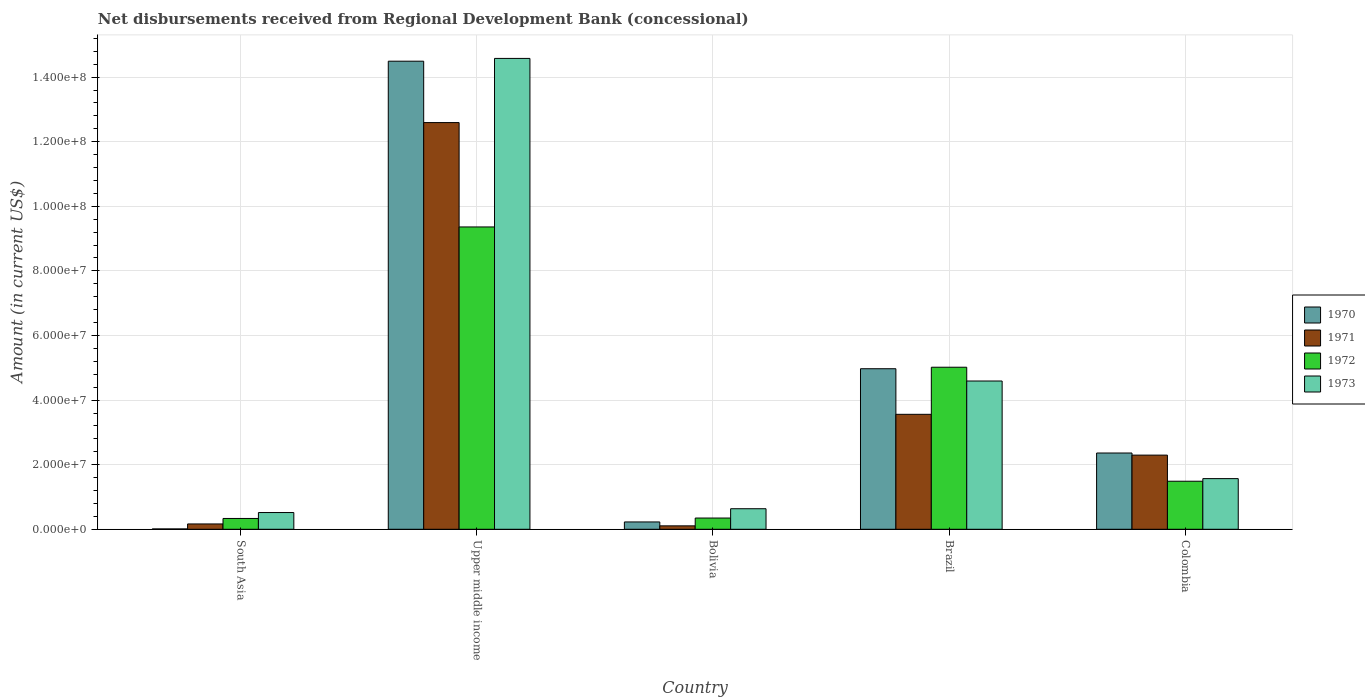How many different coloured bars are there?
Your response must be concise. 4. How many groups of bars are there?
Give a very brief answer. 5. Are the number of bars per tick equal to the number of legend labels?
Provide a short and direct response. Yes. How many bars are there on the 5th tick from the right?
Your answer should be very brief. 4. What is the label of the 2nd group of bars from the left?
Make the answer very short. Upper middle income. What is the amount of disbursements received from Regional Development Bank in 1972 in Bolivia?
Ensure brevity in your answer.  3.48e+06. Across all countries, what is the maximum amount of disbursements received from Regional Development Bank in 1973?
Ensure brevity in your answer.  1.46e+08. Across all countries, what is the minimum amount of disbursements received from Regional Development Bank in 1971?
Your response must be concise. 1.06e+06. In which country was the amount of disbursements received from Regional Development Bank in 1973 maximum?
Give a very brief answer. Upper middle income. In which country was the amount of disbursements received from Regional Development Bank in 1972 minimum?
Provide a short and direct response. South Asia. What is the total amount of disbursements received from Regional Development Bank in 1973 in the graph?
Offer a terse response. 2.19e+08. What is the difference between the amount of disbursements received from Regional Development Bank in 1970 in Brazil and that in South Asia?
Keep it short and to the point. 4.96e+07. What is the difference between the amount of disbursements received from Regional Development Bank in 1970 in Upper middle income and the amount of disbursements received from Regional Development Bank in 1973 in Brazil?
Ensure brevity in your answer.  9.90e+07. What is the average amount of disbursements received from Regional Development Bank in 1973 per country?
Your answer should be very brief. 4.38e+07. What is the difference between the amount of disbursements received from Regional Development Bank of/in 1972 and amount of disbursements received from Regional Development Bank of/in 1971 in Bolivia?
Give a very brief answer. 2.42e+06. In how many countries, is the amount of disbursements received from Regional Development Bank in 1970 greater than 100000000 US$?
Provide a succinct answer. 1. What is the ratio of the amount of disbursements received from Regional Development Bank in 1971 in Brazil to that in Upper middle income?
Your answer should be compact. 0.28. Is the amount of disbursements received from Regional Development Bank in 1970 in Bolivia less than that in Upper middle income?
Make the answer very short. Yes. Is the difference between the amount of disbursements received from Regional Development Bank in 1972 in South Asia and Upper middle income greater than the difference between the amount of disbursements received from Regional Development Bank in 1971 in South Asia and Upper middle income?
Give a very brief answer. Yes. What is the difference between the highest and the second highest amount of disbursements received from Regional Development Bank in 1972?
Your answer should be compact. 4.34e+07. What is the difference between the highest and the lowest amount of disbursements received from Regional Development Bank in 1970?
Make the answer very short. 1.45e+08. In how many countries, is the amount of disbursements received from Regional Development Bank in 1973 greater than the average amount of disbursements received from Regional Development Bank in 1973 taken over all countries?
Ensure brevity in your answer.  2. Is the sum of the amount of disbursements received from Regional Development Bank in 1973 in Bolivia and Brazil greater than the maximum amount of disbursements received from Regional Development Bank in 1971 across all countries?
Ensure brevity in your answer.  No. Is it the case that in every country, the sum of the amount of disbursements received from Regional Development Bank in 1973 and amount of disbursements received from Regional Development Bank in 1971 is greater than the sum of amount of disbursements received from Regional Development Bank in 1970 and amount of disbursements received from Regional Development Bank in 1972?
Ensure brevity in your answer.  No. Are all the bars in the graph horizontal?
Provide a short and direct response. No. How many countries are there in the graph?
Provide a succinct answer. 5. Does the graph contain grids?
Provide a short and direct response. Yes. Where does the legend appear in the graph?
Make the answer very short. Center right. How are the legend labels stacked?
Ensure brevity in your answer.  Vertical. What is the title of the graph?
Give a very brief answer. Net disbursements received from Regional Development Bank (concessional). Does "1986" appear as one of the legend labels in the graph?
Your answer should be compact. No. What is the Amount (in current US$) in 1970 in South Asia?
Make the answer very short. 1.09e+05. What is the Amount (in current US$) of 1971 in South Asia?
Your answer should be very brief. 1.65e+06. What is the Amount (in current US$) of 1972 in South Asia?
Your response must be concise. 3.35e+06. What is the Amount (in current US$) in 1973 in South Asia?
Provide a succinct answer. 5.18e+06. What is the Amount (in current US$) in 1970 in Upper middle income?
Your answer should be compact. 1.45e+08. What is the Amount (in current US$) of 1971 in Upper middle income?
Your answer should be compact. 1.26e+08. What is the Amount (in current US$) of 1972 in Upper middle income?
Provide a succinct answer. 9.36e+07. What is the Amount (in current US$) of 1973 in Upper middle income?
Your response must be concise. 1.46e+08. What is the Amount (in current US$) of 1970 in Bolivia?
Your answer should be compact. 2.27e+06. What is the Amount (in current US$) in 1971 in Bolivia?
Make the answer very short. 1.06e+06. What is the Amount (in current US$) in 1972 in Bolivia?
Offer a terse response. 3.48e+06. What is the Amount (in current US$) of 1973 in Bolivia?
Your answer should be very brief. 6.36e+06. What is the Amount (in current US$) of 1970 in Brazil?
Make the answer very short. 4.97e+07. What is the Amount (in current US$) of 1971 in Brazil?
Keep it short and to the point. 3.56e+07. What is the Amount (in current US$) of 1972 in Brazil?
Provide a short and direct response. 5.02e+07. What is the Amount (in current US$) of 1973 in Brazil?
Your answer should be compact. 4.59e+07. What is the Amount (in current US$) in 1970 in Colombia?
Ensure brevity in your answer.  2.36e+07. What is the Amount (in current US$) of 1971 in Colombia?
Your response must be concise. 2.30e+07. What is the Amount (in current US$) of 1972 in Colombia?
Keep it short and to the point. 1.49e+07. What is the Amount (in current US$) of 1973 in Colombia?
Your answer should be compact. 1.57e+07. Across all countries, what is the maximum Amount (in current US$) of 1970?
Your response must be concise. 1.45e+08. Across all countries, what is the maximum Amount (in current US$) of 1971?
Offer a very short reply. 1.26e+08. Across all countries, what is the maximum Amount (in current US$) of 1972?
Make the answer very short. 9.36e+07. Across all countries, what is the maximum Amount (in current US$) in 1973?
Provide a succinct answer. 1.46e+08. Across all countries, what is the minimum Amount (in current US$) in 1970?
Ensure brevity in your answer.  1.09e+05. Across all countries, what is the minimum Amount (in current US$) of 1971?
Make the answer very short. 1.06e+06. Across all countries, what is the minimum Amount (in current US$) of 1972?
Provide a succinct answer. 3.35e+06. Across all countries, what is the minimum Amount (in current US$) in 1973?
Keep it short and to the point. 5.18e+06. What is the total Amount (in current US$) of 1970 in the graph?
Keep it short and to the point. 2.21e+08. What is the total Amount (in current US$) in 1971 in the graph?
Make the answer very short. 1.87e+08. What is the total Amount (in current US$) in 1972 in the graph?
Your answer should be very brief. 1.65e+08. What is the total Amount (in current US$) in 1973 in the graph?
Your response must be concise. 2.19e+08. What is the difference between the Amount (in current US$) in 1970 in South Asia and that in Upper middle income?
Provide a short and direct response. -1.45e+08. What is the difference between the Amount (in current US$) in 1971 in South Asia and that in Upper middle income?
Offer a terse response. -1.24e+08. What is the difference between the Amount (in current US$) of 1972 in South Asia and that in Upper middle income?
Give a very brief answer. -9.03e+07. What is the difference between the Amount (in current US$) in 1973 in South Asia and that in Upper middle income?
Keep it short and to the point. -1.41e+08. What is the difference between the Amount (in current US$) of 1970 in South Asia and that in Bolivia?
Your answer should be very brief. -2.16e+06. What is the difference between the Amount (in current US$) in 1971 in South Asia and that in Bolivia?
Offer a terse response. 5.92e+05. What is the difference between the Amount (in current US$) of 1972 in South Asia and that in Bolivia?
Offer a terse response. -1.30e+05. What is the difference between the Amount (in current US$) in 1973 in South Asia and that in Bolivia?
Ensure brevity in your answer.  -1.18e+06. What is the difference between the Amount (in current US$) of 1970 in South Asia and that in Brazil?
Keep it short and to the point. -4.96e+07. What is the difference between the Amount (in current US$) of 1971 in South Asia and that in Brazil?
Your answer should be compact. -3.39e+07. What is the difference between the Amount (in current US$) of 1972 in South Asia and that in Brazil?
Your response must be concise. -4.68e+07. What is the difference between the Amount (in current US$) in 1973 in South Asia and that in Brazil?
Give a very brief answer. -4.07e+07. What is the difference between the Amount (in current US$) in 1970 in South Asia and that in Colombia?
Ensure brevity in your answer.  -2.35e+07. What is the difference between the Amount (in current US$) in 1971 in South Asia and that in Colombia?
Keep it short and to the point. -2.13e+07. What is the difference between the Amount (in current US$) in 1972 in South Asia and that in Colombia?
Offer a very short reply. -1.15e+07. What is the difference between the Amount (in current US$) of 1973 in South Asia and that in Colombia?
Offer a very short reply. -1.05e+07. What is the difference between the Amount (in current US$) of 1970 in Upper middle income and that in Bolivia?
Your answer should be compact. 1.43e+08. What is the difference between the Amount (in current US$) in 1971 in Upper middle income and that in Bolivia?
Offer a terse response. 1.25e+08. What is the difference between the Amount (in current US$) of 1972 in Upper middle income and that in Bolivia?
Ensure brevity in your answer.  9.01e+07. What is the difference between the Amount (in current US$) of 1973 in Upper middle income and that in Bolivia?
Ensure brevity in your answer.  1.39e+08. What is the difference between the Amount (in current US$) in 1970 in Upper middle income and that in Brazil?
Your answer should be compact. 9.52e+07. What is the difference between the Amount (in current US$) in 1971 in Upper middle income and that in Brazil?
Your answer should be compact. 9.03e+07. What is the difference between the Amount (in current US$) in 1972 in Upper middle income and that in Brazil?
Make the answer very short. 4.34e+07. What is the difference between the Amount (in current US$) in 1973 in Upper middle income and that in Brazil?
Keep it short and to the point. 9.99e+07. What is the difference between the Amount (in current US$) in 1970 in Upper middle income and that in Colombia?
Your answer should be compact. 1.21e+08. What is the difference between the Amount (in current US$) in 1971 in Upper middle income and that in Colombia?
Your answer should be very brief. 1.03e+08. What is the difference between the Amount (in current US$) in 1972 in Upper middle income and that in Colombia?
Keep it short and to the point. 7.87e+07. What is the difference between the Amount (in current US$) in 1973 in Upper middle income and that in Colombia?
Ensure brevity in your answer.  1.30e+08. What is the difference between the Amount (in current US$) of 1970 in Bolivia and that in Brazil?
Your response must be concise. -4.74e+07. What is the difference between the Amount (in current US$) of 1971 in Bolivia and that in Brazil?
Make the answer very short. -3.45e+07. What is the difference between the Amount (in current US$) in 1972 in Bolivia and that in Brazil?
Your answer should be very brief. -4.67e+07. What is the difference between the Amount (in current US$) in 1973 in Bolivia and that in Brazil?
Your answer should be compact. -3.95e+07. What is the difference between the Amount (in current US$) of 1970 in Bolivia and that in Colombia?
Your response must be concise. -2.13e+07. What is the difference between the Amount (in current US$) in 1971 in Bolivia and that in Colombia?
Provide a short and direct response. -2.19e+07. What is the difference between the Amount (in current US$) of 1972 in Bolivia and that in Colombia?
Give a very brief answer. -1.14e+07. What is the difference between the Amount (in current US$) of 1973 in Bolivia and that in Colombia?
Your answer should be compact. -9.33e+06. What is the difference between the Amount (in current US$) of 1970 in Brazil and that in Colombia?
Your response must be concise. 2.61e+07. What is the difference between the Amount (in current US$) of 1971 in Brazil and that in Colombia?
Provide a succinct answer. 1.26e+07. What is the difference between the Amount (in current US$) of 1972 in Brazil and that in Colombia?
Your answer should be very brief. 3.53e+07. What is the difference between the Amount (in current US$) in 1973 in Brazil and that in Colombia?
Make the answer very short. 3.02e+07. What is the difference between the Amount (in current US$) of 1970 in South Asia and the Amount (in current US$) of 1971 in Upper middle income?
Keep it short and to the point. -1.26e+08. What is the difference between the Amount (in current US$) of 1970 in South Asia and the Amount (in current US$) of 1972 in Upper middle income?
Offer a terse response. -9.35e+07. What is the difference between the Amount (in current US$) of 1970 in South Asia and the Amount (in current US$) of 1973 in Upper middle income?
Provide a succinct answer. -1.46e+08. What is the difference between the Amount (in current US$) in 1971 in South Asia and the Amount (in current US$) in 1972 in Upper middle income?
Provide a short and direct response. -9.20e+07. What is the difference between the Amount (in current US$) in 1971 in South Asia and the Amount (in current US$) in 1973 in Upper middle income?
Give a very brief answer. -1.44e+08. What is the difference between the Amount (in current US$) of 1972 in South Asia and the Amount (in current US$) of 1973 in Upper middle income?
Offer a very short reply. -1.42e+08. What is the difference between the Amount (in current US$) of 1970 in South Asia and the Amount (in current US$) of 1971 in Bolivia?
Offer a terse response. -9.49e+05. What is the difference between the Amount (in current US$) of 1970 in South Asia and the Amount (in current US$) of 1972 in Bolivia?
Ensure brevity in your answer.  -3.37e+06. What is the difference between the Amount (in current US$) of 1970 in South Asia and the Amount (in current US$) of 1973 in Bolivia?
Your answer should be compact. -6.25e+06. What is the difference between the Amount (in current US$) of 1971 in South Asia and the Amount (in current US$) of 1972 in Bolivia?
Ensure brevity in your answer.  -1.83e+06. What is the difference between the Amount (in current US$) in 1971 in South Asia and the Amount (in current US$) in 1973 in Bolivia?
Provide a succinct answer. -4.71e+06. What is the difference between the Amount (in current US$) of 1972 in South Asia and the Amount (in current US$) of 1973 in Bolivia?
Ensure brevity in your answer.  -3.01e+06. What is the difference between the Amount (in current US$) in 1970 in South Asia and the Amount (in current US$) in 1971 in Brazil?
Provide a succinct answer. -3.55e+07. What is the difference between the Amount (in current US$) of 1970 in South Asia and the Amount (in current US$) of 1972 in Brazil?
Your answer should be very brief. -5.01e+07. What is the difference between the Amount (in current US$) of 1970 in South Asia and the Amount (in current US$) of 1973 in Brazil?
Give a very brief answer. -4.58e+07. What is the difference between the Amount (in current US$) in 1971 in South Asia and the Amount (in current US$) in 1972 in Brazil?
Offer a terse response. -4.85e+07. What is the difference between the Amount (in current US$) in 1971 in South Asia and the Amount (in current US$) in 1973 in Brazil?
Keep it short and to the point. -4.43e+07. What is the difference between the Amount (in current US$) of 1972 in South Asia and the Amount (in current US$) of 1973 in Brazil?
Keep it short and to the point. -4.26e+07. What is the difference between the Amount (in current US$) of 1970 in South Asia and the Amount (in current US$) of 1971 in Colombia?
Your response must be concise. -2.29e+07. What is the difference between the Amount (in current US$) of 1970 in South Asia and the Amount (in current US$) of 1972 in Colombia?
Offer a very short reply. -1.48e+07. What is the difference between the Amount (in current US$) of 1970 in South Asia and the Amount (in current US$) of 1973 in Colombia?
Your response must be concise. -1.56e+07. What is the difference between the Amount (in current US$) in 1971 in South Asia and the Amount (in current US$) in 1972 in Colombia?
Keep it short and to the point. -1.32e+07. What is the difference between the Amount (in current US$) in 1971 in South Asia and the Amount (in current US$) in 1973 in Colombia?
Keep it short and to the point. -1.40e+07. What is the difference between the Amount (in current US$) in 1972 in South Asia and the Amount (in current US$) in 1973 in Colombia?
Offer a very short reply. -1.23e+07. What is the difference between the Amount (in current US$) of 1970 in Upper middle income and the Amount (in current US$) of 1971 in Bolivia?
Your response must be concise. 1.44e+08. What is the difference between the Amount (in current US$) in 1970 in Upper middle income and the Amount (in current US$) in 1972 in Bolivia?
Provide a succinct answer. 1.41e+08. What is the difference between the Amount (in current US$) in 1970 in Upper middle income and the Amount (in current US$) in 1973 in Bolivia?
Provide a succinct answer. 1.39e+08. What is the difference between the Amount (in current US$) of 1971 in Upper middle income and the Amount (in current US$) of 1972 in Bolivia?
Your answer should be very brief. 1.22e+08. What is the difference between the Amount (in current US$) in 1971 in Upper middle income and the Amount (in current US$) in 1973 in Bolivia?
Your response must be concise. 1.20e+08. What is the difference between the Amount (in current US$) in 1972 in Upper middle income and the Amount (in current US$) in 1973 in Bolivia?
Ensure brevity in your answer.  8.72e+07. What is the difference between the Amount (in current US$) of 1970 in Upper middle income and the Amount (in current US$) of 1971 in Brazil?
Your answer should be very brief. 1.09e+08. What is the difference between the Amount (in current US$) of 1970 in Upper middle income and the Amount (in current US$) of 1972 in Brazil?
Keep it short and to the point. 9.48e+07. What is the difference between the Amount (in current US$) of 1970 in Upper middle income and the Amount (in current US$) of 1973 in Brazil?
Offer a terse response. 9.90e+07. What is the difference between the Amount (in current US$) in 1971 in Upper middle income and the Amount (in current US$) in 1972 in Brazil?
Your answer should be compact. 7.57e+07. What is the difference between the Amount (in current US$) in 1971 in Upper middle income and the Amount (in current US$) in 1973 in Brazil?
Offer a terse response. 8.00e+07. What is the difference between the Amount (in current US$) of 1972 in Upper middle income and the Amount (in current US$) of 1973 in Brazil?
Give a very brief answer. 4.77e+07. What is the difference between the Amount (in current US$) of 1970 in Upper middle income and the Amount (in current US$) of 1971 in Colombia?
Your answer should be very brief. 1.22e+08. What is the difference between the Amount (in current US$) of 1970 in Upper middle income and the Amount (in current US$) of 1972 in Colombia?
Offer a terse response. 1.30e+08. What is the difference between the Amount (in current US$) in 1970 in Upper middle income and the Amount (in current US$) in 1973 in Colombia?
Your response must be concise. 1.29e+08. What is the difference between the Amount (in current US$) of 1971 in Upper middle income and the Amount (in current US$) of 1972 in Colombia?
Offer a terse response. 1.11e+08. What is the difference between the Amount (in current US$) of 1971 in Upper middle income and the Amount (in current US$) of 1973 in Colombia?
Provide a succinct answer. 1.10e+08. What is the difference between the Amount (in current US$) in 1972 in Upper middle income and the Amount (in current US$) in 1973 in Colombia?
Keep it short and to the point. 7.79e+07. What is the difference between the Amount (in current US$) of 1970 in Bolivia and the Amount (in current US$) of 1971 in Brazil?
Offer a terse response. -3.33e+07. What is the difference between the Amount (in current US$) of 1970 in Bolivia and the Amount (in current US$) of 1972 in Brazil?
Your answer should be compact. -4.79e+07. What is the difference between the Amount (in current US$) in 1970 in Bolivia and the Amount (in current US$) in 1973 in Brazil?
Your response must be concise. -4.36e+07. What is the difference between the Amount (in current US$) of 1971 in Bolivia and the Amount (in current US$) of 1972 in Brazil?
Provide a succinct answer. -4.91e+07. What is the difference between the Amount (in current US$) in 1971 in Bolivia and the Amount (in current US$) in 1973 in Brazil?
Provide a succinct answer. -4.49e+07. What is the difference between the Amount (in current US$) of 1972 in Bolivia and the Amount (in current US$) of 1973 in Brazil?
Give a very brief answer. -4.24e+07. What is the difference between the Amount (in current US$) in 1970 in Bolivia and the Amount (in current US$) in 1971 in Colombia?
Your answer should be compact. -2.07e+07. What is the difference between the Amount (in current US$) in 1970 in Bolivia and the Amount (in current US$) in 1972 in Colombia?
Ensure brevity in your answer.  -1.26e+07. What is the difference between the Amount (in current US$) in 1970 in Bolivia and the Amount (in current US$) in 1973 in Colombia?
Ensure brevity in your answer.  -1.34e+07. What is the difference between the Amount (in current US$) of 1971 in Bolivia and the Amount (in current US$) of 1972 in Colombia?
Your answer should be compact. -1.38e+07. What is the difference between the Amount (in current US$) of 1971 in Bolivia and the Amount (in current US$) of 1973 in Colombia?
Offer a terse response. -1.46e+07. What is the difference between the Amount (in current US$) of 1972 in Bolivia and the Amount (in current US$) of 1973 in Colombia?
Keep it short and to the point. -1.22e+07. What is the difference between the Amount (in current US$) in 1970 in Brazil and the Amount (in current US$) in 1971 in Colombia?
Ensure brevity in your answer.  2.67e+07. What is the difference between the Amount (in current US$) in 1970 in Brazil and the Amount (in current US$) in 1972 in Colombia?
Offer a very short reply. 3.48e+07. What is the difference between the Amount (in current US$) of 1970 in Brazil and the Amount (in current US$) of 1973 in Colombia?
Offer a very short reply. 3.40e+07. What is the difference between the Amount (in current US$) in 1971 in Brazil and the Amount (in current US$) in 1972 in Colombia?
Give a very brief answer. 2.07e+07. What is the difference between the Amount (in current US$) of 1971 in Brazil and the Amount (in current US$) of 1973 in Colombia?
Offer a terse response. 1.99e+07. What is the difference between the Amount (in current US$) in 1972 in Brazil and the Amount (in current US$) in 1973 in Colombia?
Provide a short and direct response. 3.45e+07. What is the average Amount (in current US$) in 1970 per country?
Offer a terse response. 4.41e+07. What is the average Amount (in current US$) in 1971 per country?
Provide a succinct answer. 3.74e+07. What is the average Amount (in current US$) in 1972 per country?
Give a very brief answer. 3.31e+07. What is the average Amount (in current US$) of 1973 per country?
Give a very brief answer. 4.38e+07. What is the difference between the Amount (in current US$) in 1970 and Amount (in current US$) in 1971 in South Asia?
Provide a short and direct response. -1.54e+06. What is the difference between the Amount (in current US$) of 1970 and Amount (in current US$) of 1972 in South Asia?
Give a very brief answer. -3.24e+06. What is the difference between the Amount (in current US$) in 1970 and Amount (in current US$) in 1973 in South Asia?
Your response must be concise. -5.08e+06. What is the difference between the Amount (in current US$) in 1971 and Amount (in current US$) in 1972 in South Asia?
Your response must be concise. -1.70e+06. What is the difference between the Amount (in current US$) of 1971 and Amount (in current US$) of 1973 in South Asia?
Your answer should be very brief. -3.53e+06. What is the difference between the Amount (in current US$) of 1972 and Amount (in current US$) of 1973 in South Asia?
Your response must be concise. -1.83e+06. What is the difference between the Amount (in current US$) of 1970 and Amount (in current US$) of 1971 in Upper middle income?
Your answer should be compact. 1.90e+07. What is the difference between the Amount (in current US$) in 1970 and Amount (in current US$) in 1972 in Upper middle income?
Your answer should be very brief. 5.13e+07. What is the difference between the Amount (in current US$) of 1970 and Amount (in current US$) of 1973 in Upper middle income?
Offer a very short reply. -8.58e+05. What is the difference between the Amount (in current US$) of 1971 and Amount (in current US$) of 1972 in Upper middle income?
Provide a short and direct response. 3.23e+07. What is the difference between the Amount (in current US$) of 1971 and Amount (in current US$) of 1973 in Upper middle income?
Your response must be concise. -1.99e+07. What is the difference between the Amount (in current US$) in 1972 and Amount (in current US$) in 1973 in Upper middle income?
Your response must be concise. -5.22e+07. What is the difference between the Amount (in current US$) in 1970 and Amount (in current US$) in 1971 in Bolivia?
Provide a succinct answer. 1.21e+06. What is the difference between the Amount (in current US$) of 1970 and Amount (in current US$) of 1972 in Bolivia?
Offer a very short reply. -1.21e+06. What is the difference between the Amount (in current US$) in 1970 and Amount (in current US$) in 1973 in Bolivia?
Your answer should be very brief. -4.09e+06. What is the difference between the Amount (in current US$) of 1971 and Amount (in current US$) of 1972 in Bolivia?
Provide a succinct answer. -2.42e+06. What is the difference between the Amount (in current US$) of 1971 and Amount (in current US$) of 1973 in Bolivia?
Your response must be concise. -5.30e+06. What is the difference between the Amount (in current US$) in 1972 and Amount (in current US$) in 1973 in Bolivia?
Offer a terse response. -2.88e+06. What is the difference between the Amount (in current US$) in 1970 and Amount (in current US$) in 1971 in Brazil?
Your response must be concise. 1.41e+07. What is the difference between the Amount (in current US$) in 1970 and Amount (in current US$) in 1972 in Brazil?
Your answer should be very brief. -4.68e+05. What is the difference between the Amount (in current US$) of 1970 and Amount (in current US$) of 1973 in Brazil?
Your answer should be very brief. 3.80e+06. What is the difference between the Amount (in current US$) in 1971 and Amount (in current US$) in 1972 in Brazil?
Offer a very short reply. -1.46e+07. What is the difference between the Amount (in current US$) of 1971 and Amount (in current US$) of 1973 in Brazil?
Make the answer very short. -1.03e+07. What is the difference between the Amount (in current US$) of 1972 and Amount (in current US$) of 1973 in Brazil?
Your response must be concise. 4.27e+06. What is the difference between the Amount (in current US$) in 1970 and Amount (in current US$) in 1971 in Colombia?
Give a very brief answer. 6.52e+05. What is the difference between the Amount (in current US$) of 1970 and Amount (in current US$) of 1972 in Colombia?
Give a very brief answer. 8.74e+06. What is the difference between the Amount (in current US$) in 1970 and Amount (in current US$) in 1973 in Colombia?
Your answer should be very brief. 7.93e+06. What is the difference between the Amount (in current US$) of 1971 and Amount (in current US$) of 1972 in Colombia?
Offer a very short reply. 8.08e+06. What is the difference between the Amount (in current US$) of 1971 and Amount (in current US$) of 1973 in Colombia?
Your answer should be very brief. 7.28e+06. What is the difference between the Amount (in current US$) of 1972 and Amount (in current US$) of 1973 in Colombia?
Make the answer very short. -8.09e+05. What is the ratio of the Amount (in current US$) of 1970 in South Asia to that in Upper middle income?
Provide a succinct answer. 0. What is the ratio of the Amount (in current US$) of 1971 in South Asia to that in Upper middle income?
Your answer should be very brief. 0.01. What is the ratio of the Amount (in current US$) of 1972 in South Asia to that in Upper middle income?
Offer a terse response. 0.04. What is the ratio of the Amount (in current US$) in 1973 in South Asia to that in Upper middle income?
Offer a very short reply. 0.04. What is the ratio of the Amount (in current US$) in 1970 in South Asia to that in Bolivia?
Offer a very short reply. 0.05. What is the ratio of the Amount (in current US$) of 1971 in South Asia to that in Bolivia?
Offer a terse response. 1.56. What is the ratio of the Amount (in current US$) in 1972 in South Asia to that in Bolivia?
Your answer should be compact. 0.96. What is the ratio of the Amount (in current US$) of 1973 in South Asia to that in Bolivia?
Give a very brief answer. 0.82. What is the ratio of the Amount (in current US$) of 1970 in South Asia to that in Brazil?
Your response must be concise. 0. What is the ratio of the Amount (in current US$) in 1971 in South Asia to that in Brazil?
Keep it short and to the point. 0.05. What is the ratio of the Amount (in current US$) of 1972 in South Asia to that in Brazil?
Your answer should be very brief. 0.07. What is the ratio of the Amount (in current US$) of 1973 in South Asia to that in Brazil?
Ensure brevity in your answer.  0.11. What is the ratio of the Amount (in current US$) of 1970 in South Asia to that in Colombia?
Give a very brief answer. 0. What is the ratio of the Amount (in current US$) in 1971 in South Asia to that in Colombia?
Provide a short and direct response. 0.07. What is the ratio of the Amount (in current US$) of 1972 in South Asia to that in Colombia?
Keep it short and to the point. 0.23. What is the ratio of the Amount (in current US$) in 1973 in South Asia to that in Colombia?
Give a very brief answer. 0.33. What is the ratio of the Amount (in current US$) of 1970 in Upper middle income to that in Bolivia?
Your response must be concise. 63.85. What is the ratio of the Amount (in current US$) in 1971 in Upper middle income to that in Bolivia?
Provide a succinct answer. 119.02. What is the ratio of the Amount (in current US$) in 1972 in Upper middle income to that in Bolivia?
Make the answer very short. 26.9. What is the ratio of the Amount (in current US$) of 1973 in Upper middle income to that in Bolivia?
Ensure brevity in your answer.  22.92. What is the ratio of the Amount (in current US$) in 1970 in Upper middle income to that in Brazil?
Your response must be concise. 2.92. What is the ratio of the Amount (in current US$) in 1971 in Upper middle income to that in Brazil?
Ensure brevity in your answer.  3.54. What is the ratio of the Amount (in current US$) in 1972 in Upper middle income to that in Brazil?
Give a very brief answer. 1.87. What is the ratio of the Amount (in current US$) of 1973 in Upper middle income to that in Brazil?
Keep it short and to the point. 3.18. What is the ratio of the Amount (in current US$) of 1970 in Upper middle income to that in Colombia?
Provide a succinct answer. 6.14. What is the ratio of the Amount (in current US$) of 1971 in Upper middle income to that in Colombia?
Offer a very short reply. 5.48. What is the ratio of the Amount (in current US$) in 1972 in Upper middle income to that in Colombia?
Offer a very short reply. 6.29. What is the ratio of the Amount (in current US$) of 1973 in Upper middle income to that in Colombia?
Your answer should be very brief. 9.29. What is the ratio of the Amount (in current US$) of 1970 in Bolivia to that in Brazil?
Offer a terse response. 0.05. What is the ratio of the Amount (in current US$) in 1971 in Bolivia to that in Brazil?
Ensure brevity in your answer.  0.03. What is the ratio of the Amount (in current US$) in 1972 in Bolivia to that in Brazil?
Give a very brief answer. 0.07. What is the ratio of the Amount (in current US$) of 1973 in Bolivia to that in Brazil?
Provide a short and direct response. 0.14. What is the ratio of the Amount (in current US$) in 1970 in Bolivia to that in Colombia?
Your answer should be compact. 0.1. What is the ratio of the Amount (in current US$) of 1971 in Bolivia to that in Colombia?
Make the answer very short. 0.05. What is the ratio of the Amount (in current US$) in 1972 in Bolivia to that in Colombia?
Ensure brevity in your answer.  0.23. What is the ratio of the Amount (in current US$) in 1973 in Bolivia to that in Colombia?
Ensure brevity in your answer.  0.41. What is the ratio of the Amount (in current US$) in 1970 in Brazil to that in Colombia?
Ensure brevity in your answer.  2.1. What is the ratio of the Amount (in current US$) in 1971 in Brazil to that in Colombia?
Offer a very short reply. 1.55. What is the ratio of the Amount (in current US$) of 1972 in Brazil to that in Colombia?
Give a very brief answer. 3.37. What is the ratio of the Amount (in current US$) in 1973 in Brazil to that in Colombia?
Make the answer very short. 2.93. What is the difference between the highest and the second highest Amount (in current US$) of 1970?
Give a very brief answer. 9.52e+07. What is the difference between the highest and the second highest Amount (in current US$) in 1971?
Keep it short and to the point. 9.03e+07. What is the difference between the highest and the second highest Amount (in current US$) of 1972?
Offer a terse response. 4.34e+07. What is the difference between the highest and the second highest Amount (in current US$) of 1973?
Your answer should be very brief. 9.99e+07. What is the difference between the highest and the lowest Amount (in current US$) in 1970?
Offer a very short reply. 1.45e+08. What is the difference between the highest and the lowest Amount (in current US$) in 1971?
Provide a succinct answer. 1.25e+08. What is the difference between the highest and the lowest Amount (in current US$) of 1972?
Your answer should be very brief. 9.03e+07. What is the difference between the highest and the lowest Amount (in current US$) of 1973?
Give a very brief answer. 1.41e+08. 